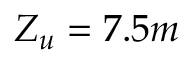<formula> <loc_0><loc_0><loc_500><loc_500>Z _ { u } = 7 . 5 m</formula> 